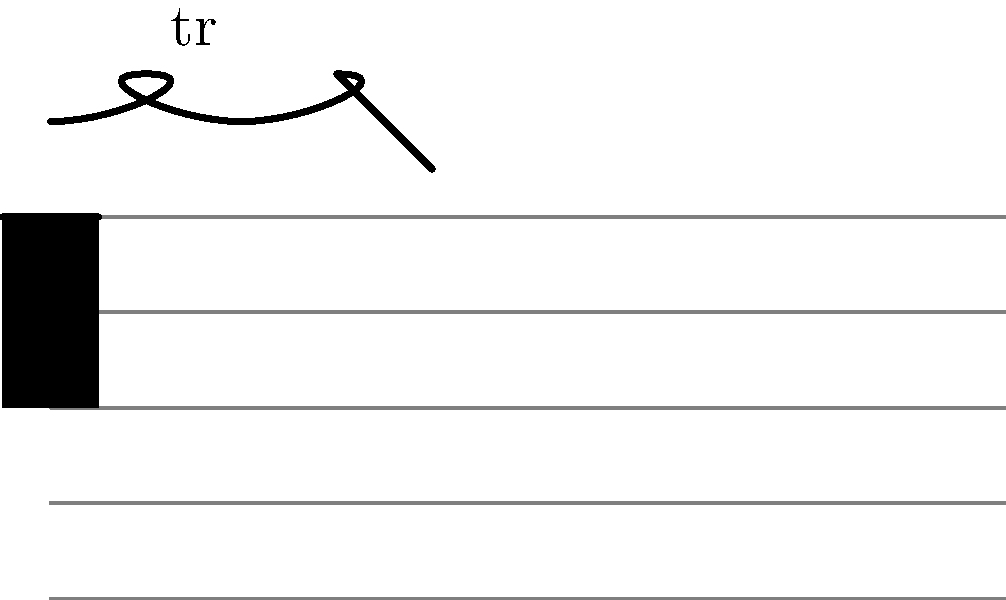In the Baroque vocal music notation shown above, what is the correct interpretation and performance of the ornament, and how should it be executed by a soprano? To interpret and perform this Baroque ornament correctly, follow these steps:

1. Identify the ornament: The symbol "tr" above the note indicates a trill.

2. Recognize the termination: The wavy line followed by a straight descending line suggests a specific ending to the trill.

3. Understand the Baroque trill execution:
   a. Start on the upper auxiliary note (the note above the written note).
   b. Alternate rapidly between the upper auxiliary and the main note.
   c. The speed of the alternation should be appropriate to the tempo and style of the piece.

4. Interpret the termination:
   a. The wavy line indicates the continuation of the trill.
   b. The descending straight line suggests a turn figure at the end of the trill.

5. Perform the ornament:
   a. Begin on the upper auxiliary note.
   b. Execute the trill for most of the note's duration.
   c. End with a turn figure: upper auxiliary - main note - lower auxiliary - main note.

6. Consider the vocal technique:
   a. Use a light, flexible voice to execute the rapid alternations.
   b. Maintain consistent breath support throughout the ornament.
   c. Ensure clear diction, especially on the initial and final notes.

7. Stylistic considerations:
   a. The trill should sound elegant and not rushed.
   b. The termination should be smooth and integrated into the trill.
   c. The overall effect should enhance the expression of the text and music.
Answer: Start on upper auxiliary, trill between upper auxiliary and main note, end with a turn figure (upper - main - lower - main). 